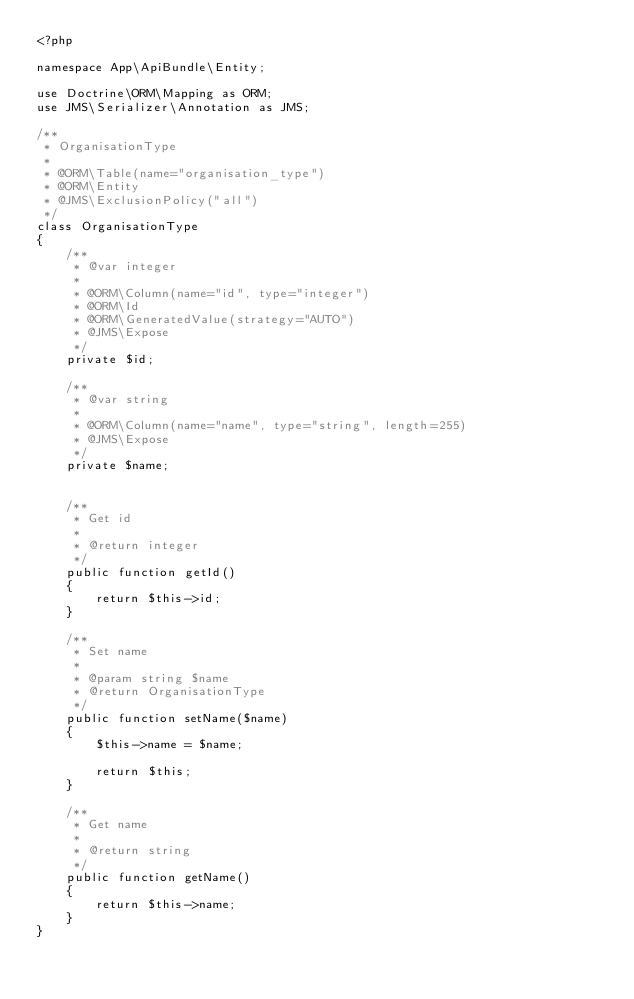<code> <loc_0><loc_0><loc_500><loc_500><_PHP_><?php

namespace App\ApiBundle\Entity;

use Doctrine\ORM\Mapping as ORM;
use JMS\Serializer\Annotation as JMS;

/**
 * OrganisationType
 *
 * @ORM\Table(name="organisation_type")
 * @ORM\Entity
 * @JMS\ExclusionPolicy("all")
 */
class OrganisationType
{
    /**
     * @var integer
     *
     * @ORM\Column(name="id", type="integer")
     * @ORM\Id
     * @ORM\GeneratedValue(strategy="AUTO")
     * @JMS\Expose
     */
    private $id;

    /**
     * @var string
     *
     * @ORM\Column(name="name", type="string", length=255)
     * @JMS\Expose
     */
    private $name;


    /**
     * Get id
     *
     * @return integer
     */
    public function getId()
    {
        return $this->id;
    }

    /**
     * Set name
     *
     * @param string $name
     * @return OrganisationType
     */
    public function setName($name)
    {
        $this->name = $name;

        return $this;
    }

    /**
     * Get name
     *
     * @return string
     */
    public function getName()
    {
        return $this->name;
    }
}
</code> 